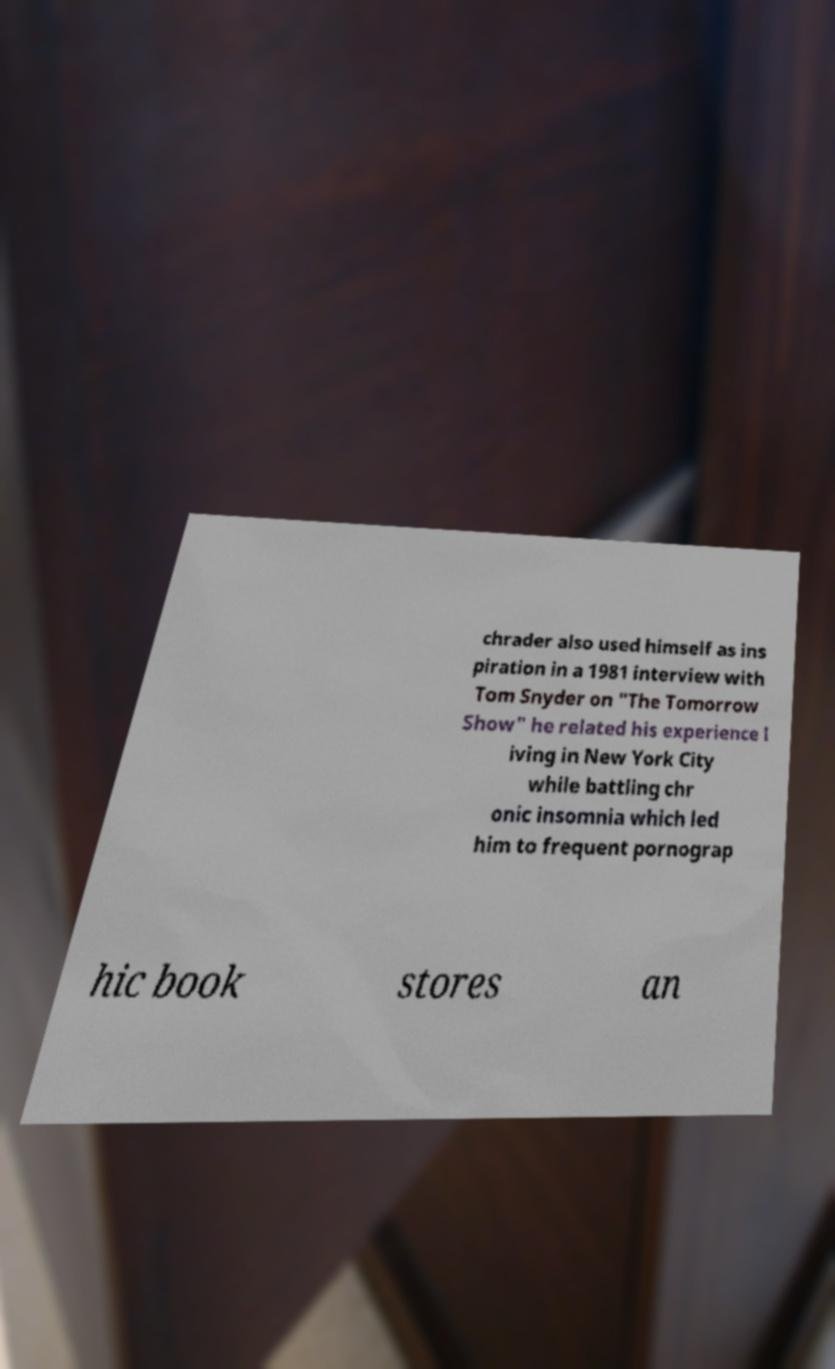Can you accurately transcribe the text from the provided image for me? chrader also used himself as ins piration in a 1981 interview with Tom Snyder on "The Tomorrow Show" he related his experience l iving in New York City while battling chr onic insomnia which led him to frequent pornograp hic book stores an 